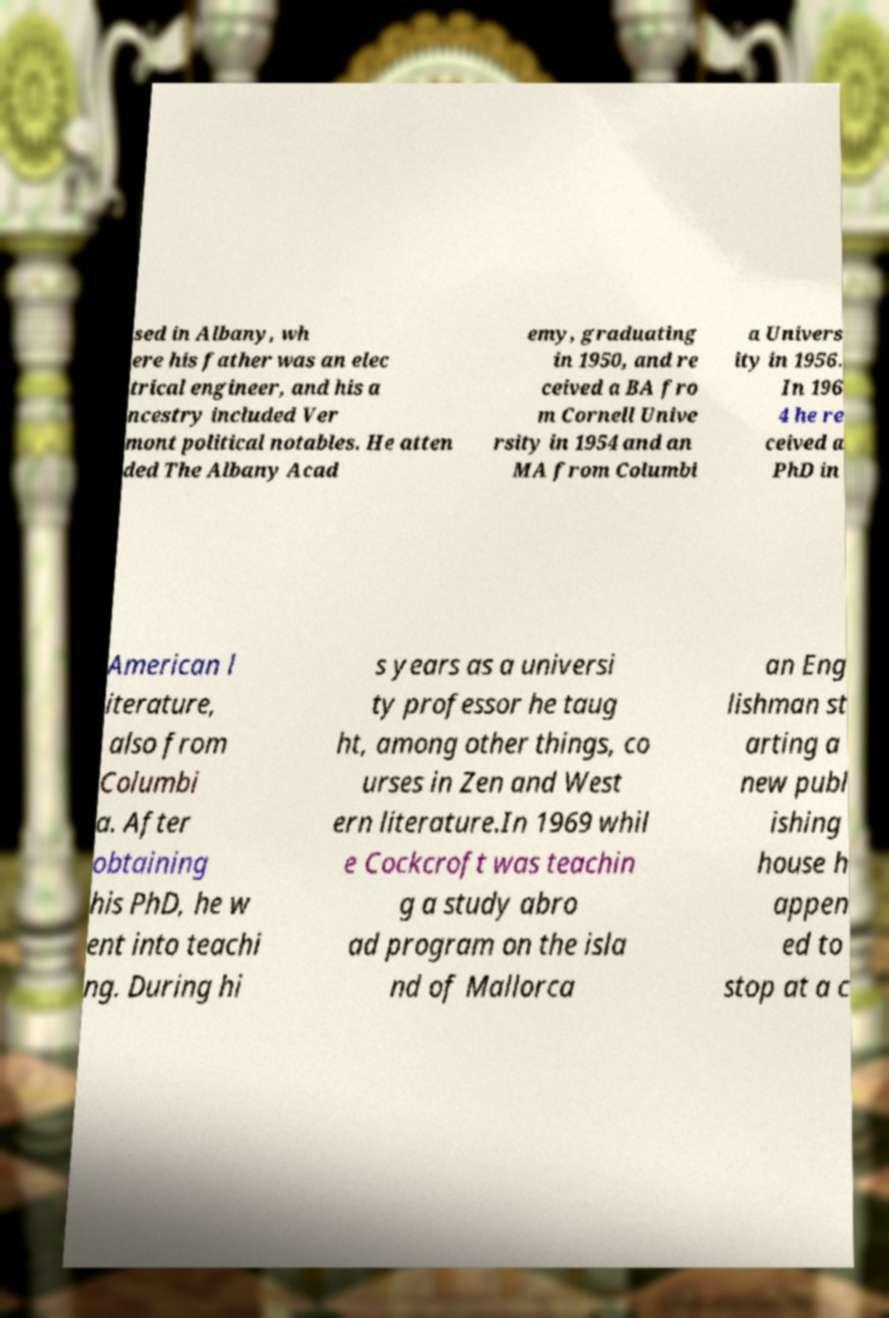Could you assist in decoding the text presented in this image and type it out clearly? sed in Albany, wh ere his father was an elec trical engineer, and his a ncestry included Ver mont political notables. He atten ded The Albany Acad emy, graduating in 1950, and re ceived a BA fro m Cornell Unive rsity in 1954 and an MA from Columbi a Univers ity in 1956. In 196 4 he re ceived a PhD in American l iterature, also from Columbi a. After obtaining his PhD, he w ent into teachi ng. During hi s years as a universi ty professor he taug ht, among other things, co urses in Zen and West ern literature.In 1969 whil e Cockcroft was teachin g a study abro ad program on the isla nd of Mallorca an Eng lishman st arting a new publ ishing house h appen ed to stop at a c 